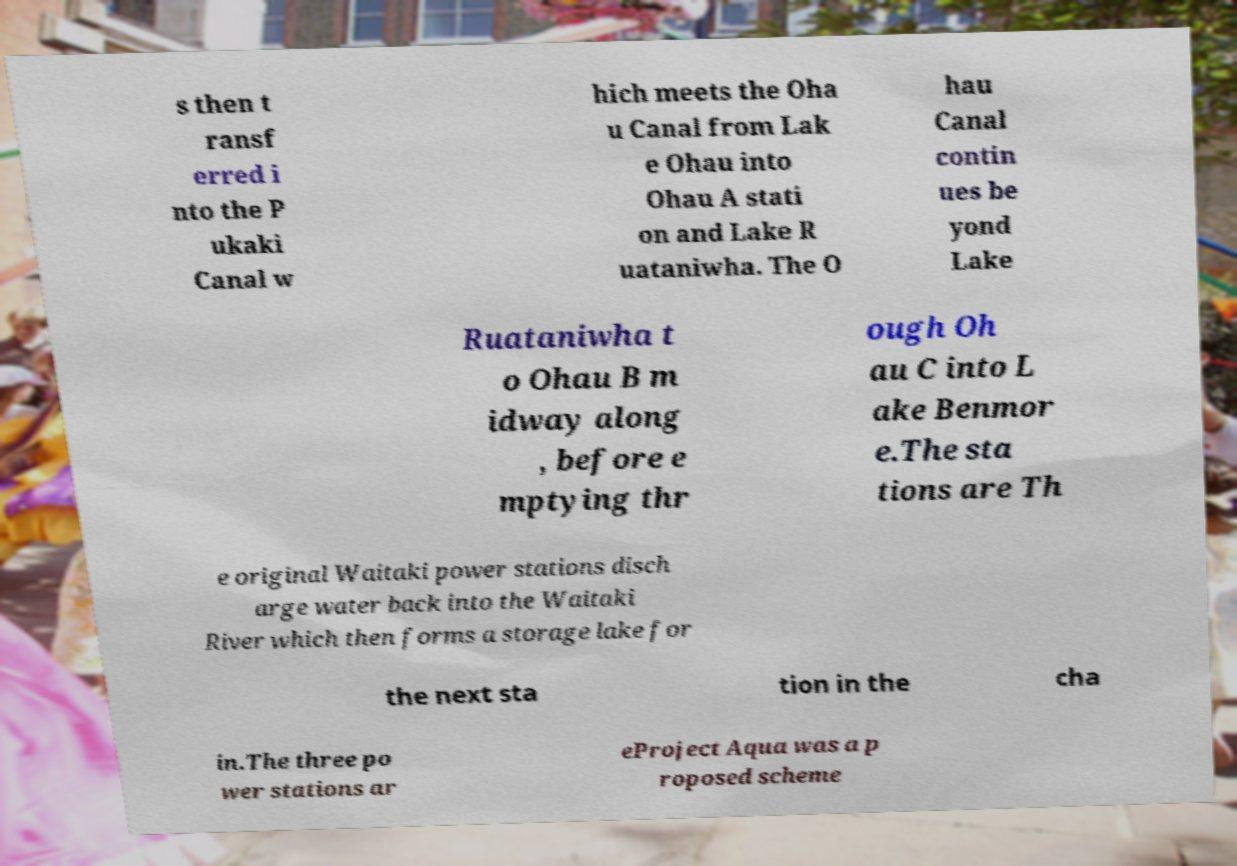I need the written content from this picture converted into text. Can you do that? s then t ransf erred i nto the P ukaki Canal w hich meets the Oha u Canal from Lak e Ohau into Ohau A stati on and Lake R uataniwha. The O hau Canal contin ues be yond Lake Ruataniwha t o Ohau B m idway along , before e mptying thr ough Oh au C into L ake Benmor e.The sta tions are Th e original Waitaki power stations disch arge water back into the Waitaki River which then forms a storage lake for the next sta tion in the cha in.The three po wer stations ar eProject Aqua was a p roposed scheme 